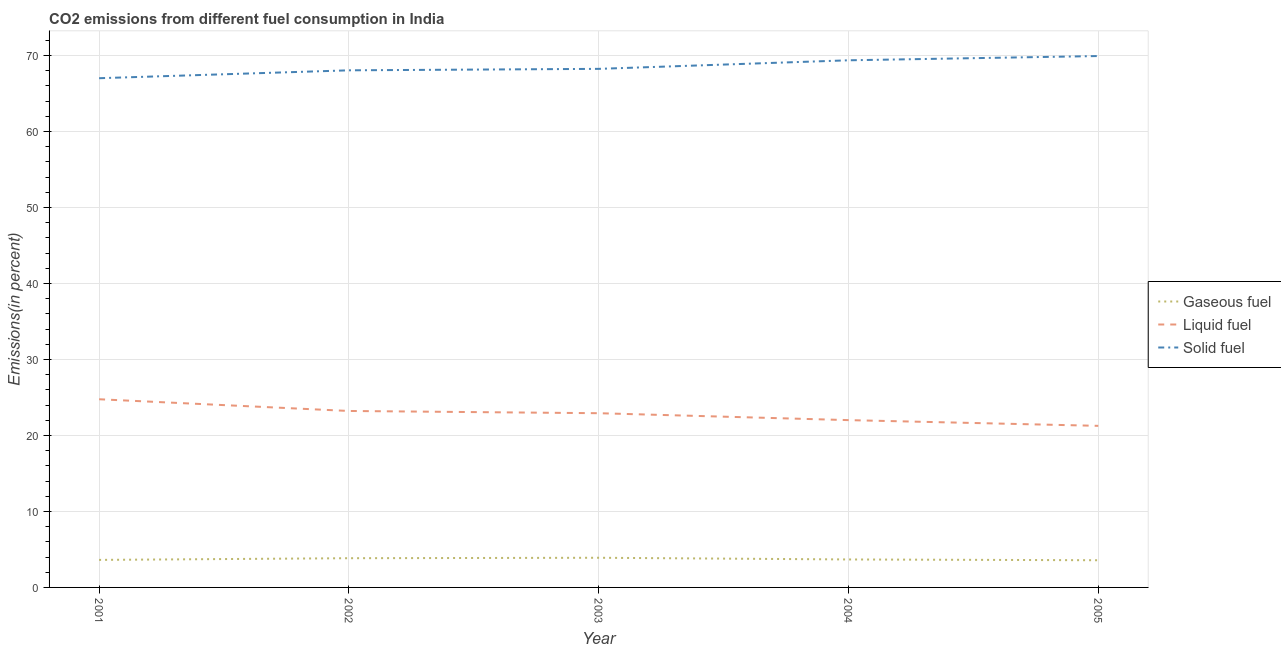How many different coloured lines are there?
Offer a terse response. 3. What is the percentage of gaseous fuel emission in 2003?
Offer a terse response. 3.9. Across all years, what is the maximum percentage of liquid fuel emission?
Your response must be concise. 24.76. Across all years, what is the minimum percentage of gaseous fuel emission?
Provide a short and direct response. 3.58. What is the total percentage of gaseous fuel emission in the graph?
Keep it short and to the point. 18.63. What is the difference between the percentage of liquid fuel emission in 2002 and that in 2003?
Your answer should be compact. 0.29. What is the difference between the percentage of gaseous fuel emission in 2005 and the percentage of solid fuel emission in 2003?
Your answer should be very brief. -64.65. What is the average percentage of gaseous fuel emission per year?
Your response must be concise. 3.73. In the year 2004, what is the difference between the percentage of solid fuel emission and percentage of gaseous fuel emission?
Your answer should be very brief. 65.68. In how many years, is the percentage of gaseous fuel emission greater than 30 %?
Your answer should be very brief. 0. What is the ratio of the percentage of gaseous fuel emission in 2002 to that in 2004?
Keep it short and to the point. 1.04. What is the difference between the highest and the second highest percentage of liquid fuel emission?
Your answer should be compact. 1.54. What is the difference between the highest and the lowest percentage of liquid fuel emission?
Keep it short and to the point. 3.5. Is the sum of the percentage of gaseous fuel emission in 2001 and 2003 greater than the maximum percentage of liquid fuel emission across all years?
Your response must be concise. No. Is it the case that in every year, the sum of the percentage of gaseous fuel emission and percentage of liquid fuel emission is greater than the percentage of solid fuel emission?
Ensure brevity in your answer.  No. Is the percentage of liquid fuel emission strictly greater than the percentage of solid fuel emission over the years?
Your answer should be very brief. No. What is the difference between two consecutive major ticks on the Y-axis?
Offer a terse response. 10. Are the values on the major ticks of Y-axis written in scientific E-notation?
Your response must be concise. No. How many legend labels are there?
Give a very brief answer. 3. How are the legend labels stacked?
Your response must be concise. Vertical. What is the title of the graph?
Ensure brevity in your answer.  CO2 emissions from different fuel consumption in India. What is the label or title of the X-axis?
Offer a very short reply. Year. What is the label or title of the Y-axis?
Give a very brief answer. Emissions(in percent). What is the Emissions(in percent) of Gaseous fuel in 2001?
Your answer should be compact. 3.62. What is the Emissions(in percent) in Liquid fuel in 2001?
Your response must be concise. 24.76. What is the Emissions(in percent) of Solid fuel in 2001?
Provide a succinct answer. 67. What is the Emissions(in percent) in Gaseous fuel in 2002?
Your answer should be very brief. 3.85. What is the Emissions(in percent) in Liquid fuel in 2002?
Offer a very short reply. 23.22. What is the Emissions(in percent) in Solid fuel in 2002?
Keep it short and to the point. 68.04. What is the Emissions(in percent) in Gaseous fuel in 2003?
Keep it short and to the point. 3.9. What is the Emissions(in percent) of Liquid fuel in 2003?
Provide a short and direct response. 22.92. What is the Emissions(in percent) in Solid fuel in 2003?
Give a very brief answer. 68.23. What is the Emissions(in percent) of Gaseous fuel in 2004?
Offer a very short reply. 3.68. What is the Emissions(in percent) in Liquid fuel in 2004?
Your answer should be very brief. 22.01. What is the Emissions(in percent) in Solid fuel in 2004?
Make the answer very short. 69.36. What is the Emissions(in percent) in Gaseous fuel in 2005?
Your response must be concise. 3.58. What is the Emissions(in percent) of Liquid fuel in 2005?
Ensure brevity in your answer.  21.26. What is the Emissions(in percent) of Solid fuel in 2005?
Offer a very short reply. 69.92. Across all years, what is the maximum Emissions(in percent) in Gaseous fuel?
Your response must be concise. 3.9. Across all years, what is the maximum Emissions(in percent) of Liquid fuel?
Your response must be concise. 24.76. Across all years, what is the maximum Emissions(in percent) of Solid fuel?
Provide a short and direct response. 69.92. Across all years, what is the minimum Emissions(in percent) of Gaseous fuel?
Your response must be concise. 3.58. Across all years, what is the minimum Emissions(in percent) in Liquid fuel?
Offer a very short reply. 21.26. Across all years, what is the minimum Emissions(in percent) of Solid fuel?
Ensure brevity in your answer.  67. What is the total Emissions(in percent) in Gaseous fuel in the graph?
Provide a succinct answer. 18.63. What is the total Emissions(in percent) in Liquid fuel in the graph?
Your response must be concise. 114.17. What is the total Emissions(in percent) in Solid fuel in the graph?
Ensure brevity in your answer.  342.55. What is the difference between the Emissions(in percent) of Gaseous fuel in 2001 and that in 2002?
Give a very brief answer. -0.22. What is the difference between the Emissions(in percent) of Liquid fuel in 2001 and that in 2002?
Provide a succinct answer. 1.54. What is the difference between the Emissions(in percent) of Solid fuel in 2001 and that in 2002?
Provide a succinct answer. -1.04. What is the difference between the Emissions(in percent) in Gaseous fuel in 2001 and that in 2003?
Ensure brevity in your answer.  -0.28. What is the difference between the Emissions(in percent) in Liquid fuel in 2001 and that in 2003?
Make the answer very short. 1.84. What is the difference between the Emissions(in percent) of Solid fuel in 2001 and that in 2003?
Your answer should be compact. -1.23. What is the difference between the Emissions(in percent) of Gaseous fuel in 2001 and that in 2004?
Provide a succinct answer. -0.06. What is the difference between the Emissions(in percent) in Liquid fuel in 2001 and that in 2004?
Your answer should be compact. 2.75. What is the difference between the Emissions(in percent) of Solid fuel in 2001 and that in 2004?
Your answer should be very brief. -2.36. What is the difference between the Emissions(in percent) in Gaseous fuel in 2001 and that in 2005?
Provide a succinct answer. 0.04. What is the difference between the Emissions(in percent) of Liquid fuel in 2001 and that in 2005?
Your answer should be very brief. 3.5. What is the difference between the Emissions(in percent) in Solid fuel in 2001 and that in 2005?
Offer a very short reply. -2.92. What is the difference between the Emissions(in percent) in Gaseous fuel in 2002 and that in 2003?
Provide a short and direct response. -0.06. What is the difference between the Emissions(in percent) of Liquid fuel in 2002 and that in 2003?
Offer a very short reply. 0.29. What is the difference between the Emissions(in percent) of Solid fuel in 2002 and that in 2003?
Offer a terse response. -0.19. What is the difference between the Emissions(in percent) in Gaseous fuel in 2002 and that in 2004?
Your answer should be compact. 0.17. What is the difference between the Emissions(in percent) of Liquid fuel in 2002 and that in 2004?
Offer a terse response. 1.2. What is the difference between the Emissions(in percent) of Solid fuel in 2002 and that in 2004?
Offer a terse response. -1.32. What is the difference between the Emissions(in percent) of Gaseous fuel in 2002 and that in 2005?
Offer a terse response. 0.27. What is the difference between the Emissions(in percent) of Liquid fuel in 2002 and that in 2005?
Your response must be concise. 1.96. What is the difference between the Emissions(in percent) in Solid fuel in 2002 and that in 2005?
Provide a succinct answer. -1.88. What is the difference between the Emissions(in percent) of Gaseous fuel in 2003 and that in 2004?
Ensure brevity in your answer.  0.22. What is the difference between the Emissions(in percent) of Liquid fuel in 2003 and that in 2004?
Ensure brevity in your answer.  0.91. What is the difference between the Emissions(in percent) in Solid fuel in 2003 and that in 2004?
Your answer should be compact. -1.13. What is the difference between the Emissions(in percent) of Gaseous fuel in 2003 and that in 2005?
Provide a short and direct response. 0.33. What is the difference between the Emissions(in percent) in Liquid fuel in 2003 and that in 2005?
Offer a terse response. 1.66. What is the difference between the Emissions(in percent) of Solid fuel in 2003 and that in 2005?
Ensure brevity in your answer.  -1.69. What is the difference between the Emissions(in percent) of Gaseous fuel in 2004 and that in 2005?
Your answer should be compact. 0.1. What is the difference between the Emissions(in percent) of Liquid fuel in 2004 and that in 2005?
Ensure brevity in your answer.  0.75. What is the difference between the Emissions(in percent) in Solid fuel in 2004 and that in 2005?
Provide a short and direct response. -0.56. What is the difference between the Emissions(in percent) in Gaseous fuel in 2001 and the Emissions(in percent) in Liquid fuel in 2002?
Your answer should be compact. -19.6. What is the difference between the Emissions(in percent) of Gaseous fuel in 2001 and the Emissions(in percent) of Solid fuel in 2002?
Keep it short and to the point. -64.42. What is the difference between the Emissions(in percent) in Liquid fuel in 2001 and the Emissions(in percent) in Solid fuel in 2002?
Make the answer very short. -43.28. What is the difference between the Emissions(in percent) of Gaseous fuel in 2001 and the Emissions(in percent) of Liquid fuel in 2003?
Your answer should be very brief. -19.3. What is the difference between the Emissions(in percent) in Gaseous fuel in 2001 and the Emissions(in percent) in Solid fuel in 2003?
Your answer should be very brief. -64.61. What is the difference between the Emissions(in percent) of Liquid fuel in 2001 and the Emissions(in percent) of Solid fuel in 2003?
Your response must be concise. -43.47. What is the difference between the Emissions(in percent) of Gaseous fuel in 2001 and the Emissions(in percent) of Liquid fuel in 2004?
Ensure brevity in your answer.  -18.39. What is the difference between the Emissions(in percent) in Gaseous fuel in 2001 and the Emissions(in percent) in Solid fuel in 2004?
Offer a very short reply. -65.74. What is the difference between the Emissions(in percent) of Liquid fuel in 2001 and the Emissions(in percent) of Solid fuel in 2004?
Your answer should be compact. -44.6. What is the difference between the Emissions(in percent) in Gaseous fuel in 2001 and the Emissions(in percent) in Liquid fuel in 2005?
Offer a very short reply. -17.64. What is the difference between the Emissions(in percent) in Gaseous fuel in 2001 and the Emissions(in percent) in Solid fuel in 2005?
Make the answer very short. -66.3. What is the difference between the Emissions(in percent) of Liquid fuel in 2001 and the Emissions(in percent) of Solid fuel in 2005?
Offer a very short reply. -45.16. What is the difference between the Emissions(in percent) of Gaseous fuel in 2002 and the Emissions(in percent) of Liquid fuel in 2003?
Keep it short and to the point. -19.08. What is the difference between the Emissions(in percent) of Gaseous fuel in 2002 and the Emissions(in percent) of Solid fuel in 2003?
Your answer should be very brief. -64.39. What is the difference between the Emissions(in percent) in Liquid fuel in 2002 and the Emissions(in percent) in Solid fuel in 2003?
Your answer should be very brief. -45.01. What is the difference between the Emissions(in percent) in Gaseous fuel in 2002 and the Emissions(in percent) in Liquid fuel in 2004?
Provide a succinct answer. -18.17. What is the difference between the Emissions(in percent) in Gaseous fuel in 2002 and the Emissions(in percent) in Solid fuel in 2004?
Offer a terse response. -65.51. What is the difference between the Emissions(in percent) in Liquid fuel in 2002 and the Emissions(in percent) in Solid fuel in 2004?
Provide a short and direct response. -46.14. What is the difference between the Emissions(in percent) of Gaseous fuel in 2002 and the Emissions(in percent) of Liquid fuel in 2005?
Your response must be concise. -17.42. What is the difference between the Emissions(in percent) in Gaseous fuel in 2002 and the Emissions(in percent) in Solid fuel in 2005?
Offer a very short reply. -66.07. What is the difference between the Emissions(in percent) of Liquid fuel in 2002 and the Emissions(in percent) of Solid fuel in 2005?
Offer a very short reply. -46.7. What is the difference between the Emissions(in percent) of Gaseous fuel in 2003 and the Emissions(in percent) of Liquid fuel in 2004?
Offer a very short reply. -18.11. What is the difference between the Emissions(in percent) of Gaseous fuel in 2003 and the Emissions(in percent) of Solid fuel in 2004?
Your response must be concise. -65.46. What is the difference between the Emissions(in percent) in Liquid fuel in 2003 and the Emissions(in percent) in Solid fuel in 2004?
Offer a very short reply. -46.44. What is the difference between the Emissions(in percent) in Gaseous fuel in 2003 and the Emissions(in percent) in Liquid fuel in 2005?
Make the answer very short. -17.36. What is the difference between the Emissions(in percent) of Gaseous fuel in 2003 and the Emissions(in percent) of Solid fuel in 2005?
Your answer should be compact. -66.02. What is the difference between the Emissions(in percent) of Liquid fuel in 2003 and the Emissions(in percent) of Solid fuel in 2005?
Your answer should be compact. -47. What is the difference between the Emissions(in percent) in Gaseous fuel in 2004 and the Emissions(in percent) in Liquid fuel in 2005?
Your answer should be compact. -17.58. What is the difference between the Emissions(in percent) in Gaseous fuel in 2004 and the Emissions(in percent) in Solid fuel in 2005?
Provide a short and direct response. -66.24. What is the difference between the Emissions(in percent) in Liquid fuel in 2004 and the Emissions(in percent) in Solid fuel in 2005?
Provide a short and direct response. -47.9. What is the average Emissions(in percent) in Gaseous fuel per year?
Keep it short and to the point. 3.73. What is the average Emissions(in percent) in Liquid fuel per year?
Offer a very short reply. 22.83. What is the average Emissions(in percent) in Solid fuel per year?
Provide a succinct answer. 68.51. In the year 2001, what is the difference between the Emissions(in percent) in Gaseous fuel and Emissions(in percent) in Liquid fuel?
Keep it short and to the point. -21.14. In the year 2001, what is the difference between the Emissions(in percent) in Gaseous fuel and Emissions(in percent) in Solid fuel?
Provide a succinct answer. -63.38. In the year 2001, what is the difference between the Emissions(in percent) in Liquid fuel and Emissions(in percent) in Solid fuel?
Give a very brief answer. -42.24. In the year 2002, what is the difference between the Emissions(in percent) of Gaseous fuel and Emissions(in percent) of Liquid fuel?
Provide a short and direct response. -19.37. In the year 2002, what is the difference between the Emissions(in percent) of Gaseous fuel and Emissions(in percent) of Solid fuel?
Offer a very short reply. -64.19. In the year 2002, what is the difference between the Emissions(in percent) in Liquid fuel and Emissions(in percent) in Solid fuel?
Offer a terse response. -44.82. In the year 2003, what is the difference between the Emissions(in percent) in Gaseous fuel and Emissions(in percent) in Liquid fuel?
Make the answer very short. -19.02. In the year 2003, what is the difference between the Emissions(in percent) of Gaseous fuel and Emissions(in percent) of Solid fuel?
Your response must be concise. -64.33. In the year 2003, what is the difference between the Emissions(in percent) in Liquid fuel and Emissions(in percent) in Solid fuel?
Offer a terse response. -45.31. In the year 2004, what is the difference between the Emissions(in percent) of Gaseous fuel and Emissions(in percent) of Liquid fuel?
Make the answer very short. -18.33. In the year 2004, what is the difference between the Emissions(in percent) in Gaseous fuel and Emissions(in percent) in Solid fuel?
Your answer should be very brief. -65.68. In the year 2004, what is the difference between the Emissions(in percent) in Liquid fuel and Emissions(in percent) in Solid fuel?
Give a very brief answer. -47.34. In the year 2005, what is the difference between the Emissions(in percent) of Gaseous fuel and Emissions(in percent) of Liquid fuel?
Your answer should be compact. -17.68. In the year 2005, what is the difference between the Emissions(in percent) in Gaseous fuel and Emissions(in percent) in Solid fuel?
Provide a succinct answer. -66.34. In the year 2005, what is the difference between the Emissions(in percent) of Liquid fuel and Emissions(in percent) of Solid fuel?
Your response must be concise. -48.66. What is the ratio of the Emissions(in percent) of Gaseous fuel in 2001 to that in 2002?
Provide a short and direct response. 0.94. What is the ratio of the Emissions(in percent) in Liquid fuel in 2001 to that in 2002?
Your answer should be compact. 1.07. What is the ratio of the Emissions(in percent) of Solid fuel in 2001 to that in 2002?
Provide a short and direct response. 0.98. What is the ratio of the Emissions(in percent) in Gaseous fuel in 2001 to that in 2003?
Provide a short and direct response. 0.93. What is the ratio of the Emissions(in percent) in Liquid fuel in 2001 to that in 2003?
Offer a terse response. 1.08. What is the ratio of the Emissions(in percent) of Gaseous fuel in 2001 to that in 2004?
Make the answer very short. 0.98. What is the ratio of the Emissions(in percent) in Liquid fuel in 2001 to that in 2004?
Provide a short and direct response. 1.12. What is the ratio of the Emissions(in percent) in Gaseous fuel in 2001 to that in 2005?
Provide a short and direct response. 1.01. What is the ratio of the Emissions(in percent) of Liquid fuel in 2001 to that in 2005?
Your response must be concise. 1.16. What is the ratio of the Emissions(in percent) of Solid fuel in 2001 to that in 2005?
Your response must be concise. 0.96. What is the ratio of the Emissions(in percent) in Gaseous fuel in 2002 to that in 2003?
Make the answer very short. 0.99. What is the ratio of the Emissions(in percent) of Liquid fuel in 2002 to that in 2003?
Your response must be concise. 1.01. What is the ratio of the Emissions(in percent) of Solid fuel in 2002 to that in 2003?
Your answer should be compact. 1. What is the ratio of the Emissions(in percent) of Gaseous fuel in 2002 to that in 2004?
Offer a very short reply. 1.04. What is the ratio of the Emissions(in percent) in Liquid fuel in 2002 to that in 2004?
Ensure brevity in your answer.  1.05. What is the ratio of the Emissions(in percent) of Solid fuel in 2002 to that in 2004?
Provide a succinct answer. 0.98. What is the ratio of the Emissions(in percent) of Gaseous fuel in 2002 to that in 2005?
Offer a terse response. 1.07. What is the ratio of the Emissions(in percent) in Liquid fuel in 2002 to that in 2005?
Your answer should be compact. 1.09. What is the ratio of the Emissions(in percent) of Solid fuel in 2002 to that in 2005?
Offer a terse response. 0.97. What is the ratio of the Emissions(in percent) in Gaseous fuel in 2003 to that in 2004?
Provide a short and direct response. 1.06. What is the ratio of the Emissions(in percent) in Liquid fuel in 2003 to that in 2004?
Provide a succinct answer. 1.04. What is the ratio of the Emissions(in percent) of Solid fuel in 2003 to that in 2004?
Your answer should be very brief. 0.98. What is the ratio of the Emissions(in percent) in Gaseous fuel in 2003 to that in 2005?
Your response must be concise. 1.09. What is the ratio of the Emissions(in percent) in Liquid fuel in 2003 to that in 2005?
Your answer should be compact. 1.08. What is the ratio of the Emissions(in percent) in Solid fuel in 2003 to that in 2005?
Provide a short and direct response. 0.98. What is the ratio of the Emissions(in percent) in Gaseous fuel in 2004 to that in 2005?
Make the answer very short. 1.03. What is the ratio of the Emissions(in percent) of Liquid fuel in 2004 to that in 2005?
Provide a succinct answer. 1.04. What is the ratio of the Emissions(in percent) of Solid fuel in 2004 to that in 2005?
Provide a succinct answer. 0.99. What is the difference between the highest and the second highest Emissions(in percent) in Gaseous fuel?
Your response must be concise. 0.06. What is the difference between the highest and the second highest Emissions(in percent) in Liquid fuel?
Make the answer very short. 1.54. What is the difference between the highest and the second highest Emissions(in percent) of Solid fuel?
Offer a terse response. 0.56. What is the difference between the highest and the lowest Emissions(in percent) in Gaseous fuel?
Your answer should be compact. 0.33. What is the difference between the highest and the lowest Emissions(in percent) of Liquid fuel?
Make the answer very short. 3.5. What is the difference between the highest and the lowest Emissions(in percent) of Solid fuel?
Give a very brief answer. 2.92. 